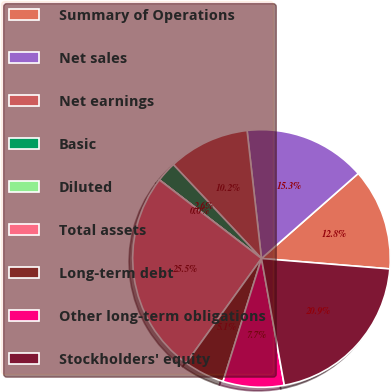<chart> <loc_0><loc_0><loc_500><loc_500><pie_chart><fcel>Summary of Operations<fcel>Net sales<fcel>Net earnings<fcel>Basic<fcel>Diluted<fcel>Total assets<fcel>Long-term debt<fcel>Other long-term obligations<fcel>Stockholders' equity<nl><fcel>12.76%<fcel>15.31%<fcel>10.21%<fcel>2.56%<fcel>0.01%<fcel>25.5%<fcel>5.11%<fcel>7.66%<fcel>20.87%<nl></chart> 